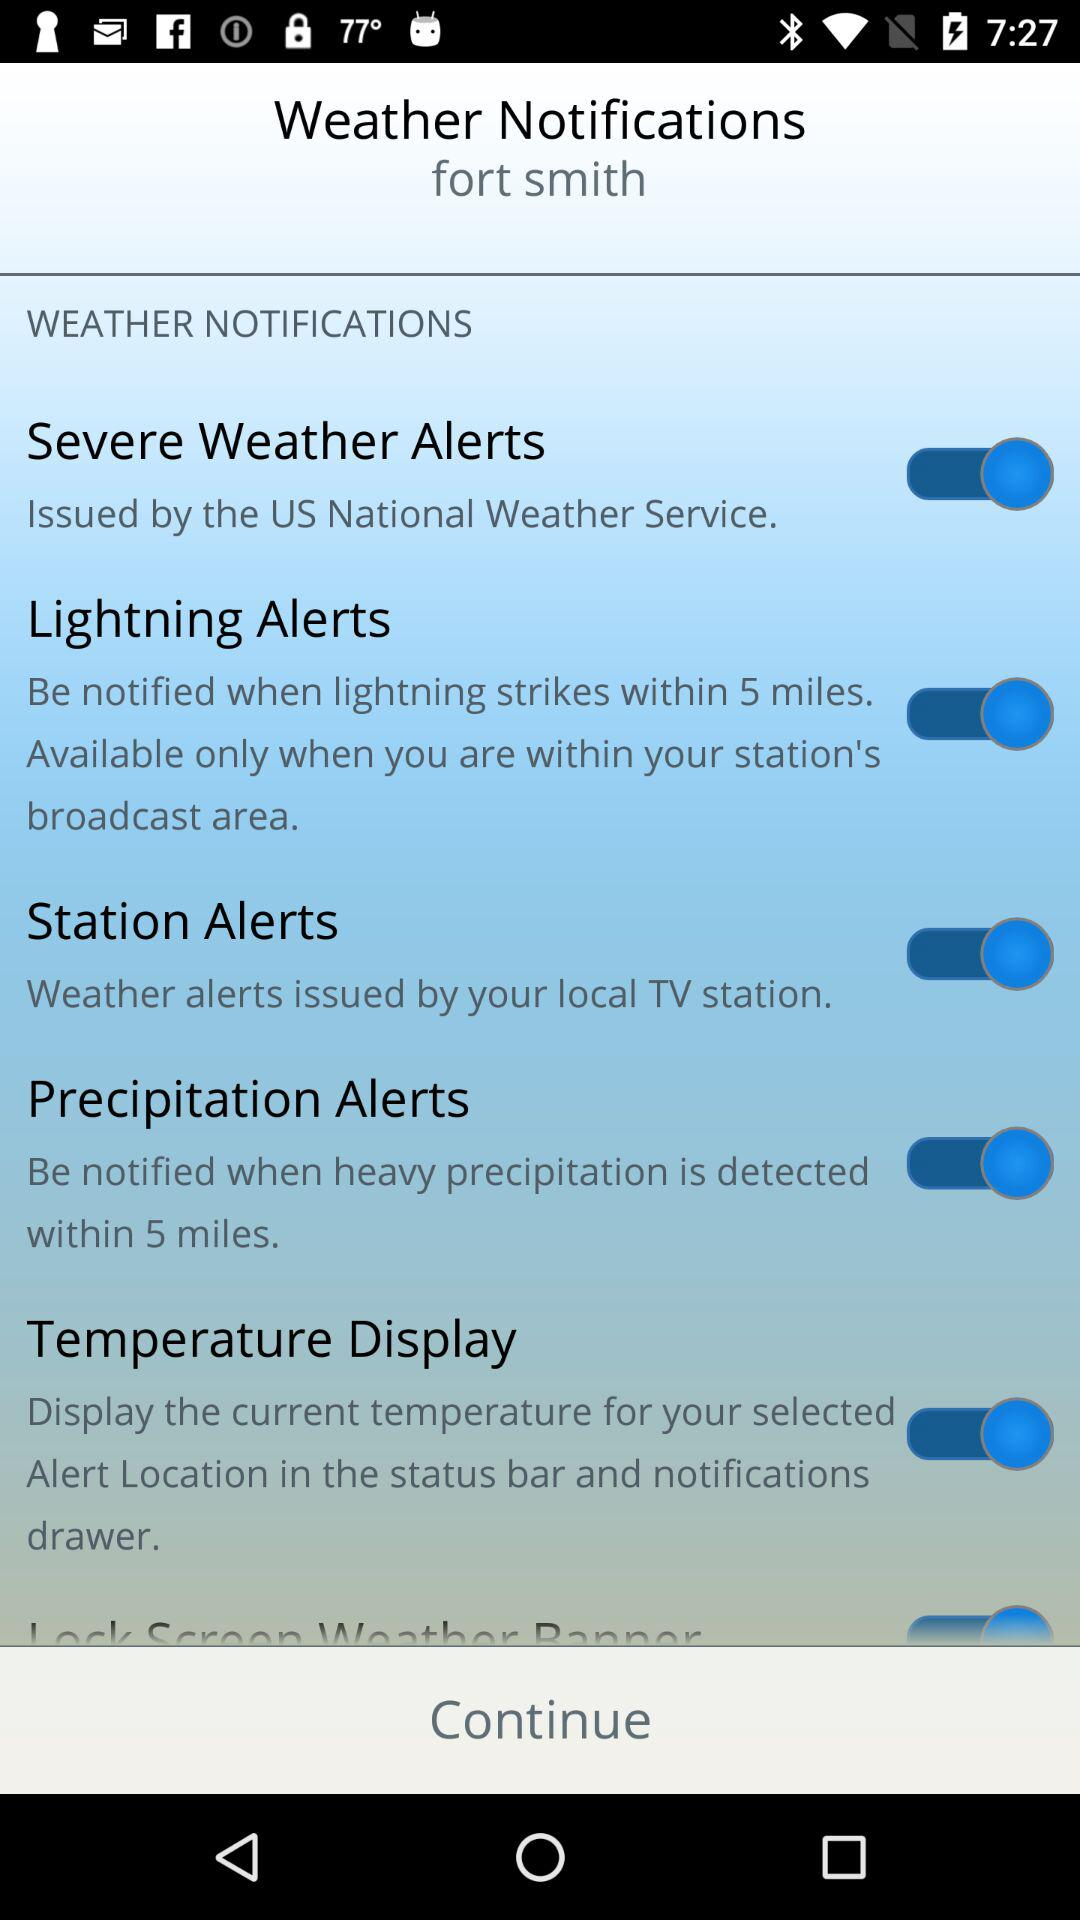What is the status of the "Lightning Alerts"? The status is on. 